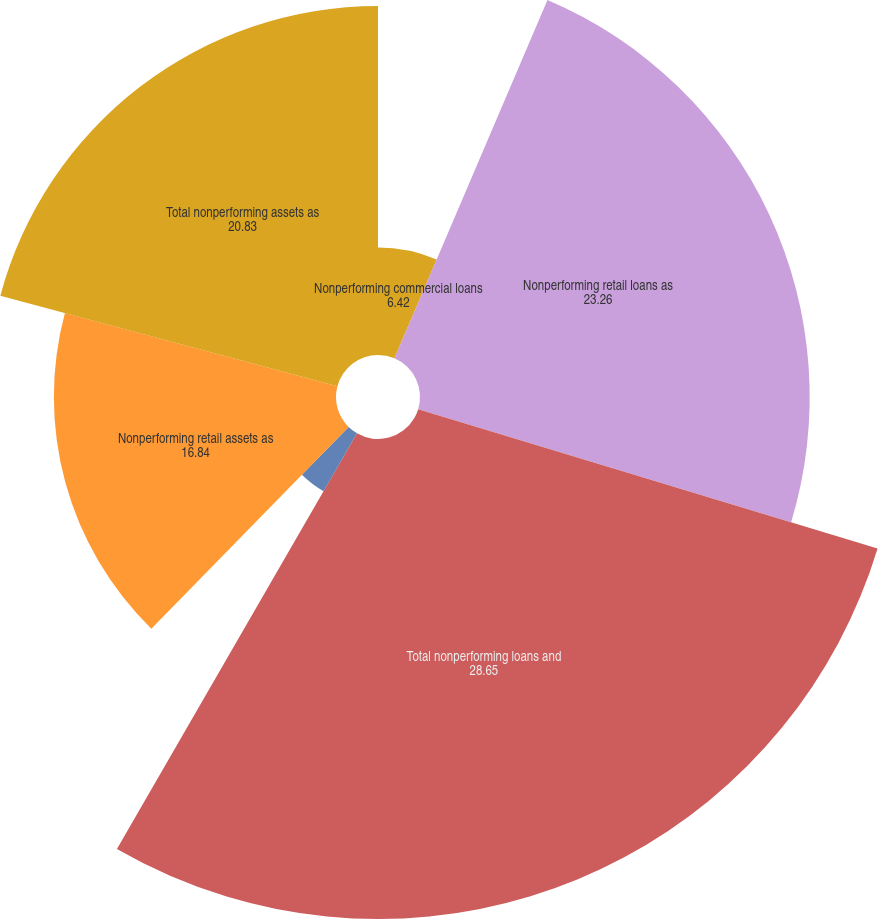Convert chart. <chart><loc_0><loc_0><loc_500><loc_500><pie_chart><fcel>Nonperforming commercial loans<fcel>Nonperforming retail loans as<fcel>Total nonperforming loans and<fcel>Nonperforming commercial<fcel>Nonperforming retail assets as<fcel>Total nonperforming assets as<nl><fcel>6.42%<fcel>23.26%<fcel>28.65%<fcel>3.99%<fcel>16.84%<fcel>20.83%<nl></chart> 